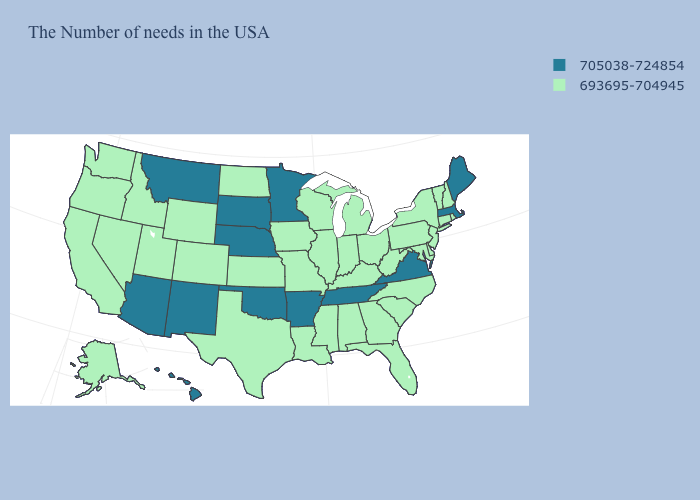What is the value of Nebraska?
Concise answer only. 705038-724854. What is the value of Colorado?
Short answer required. 693695-704945. What is the value of North Carolina?
Short answer required. 693695-704945. What is the highest value in states that border Virginia?
Quick response, please. 705038-724854. What is the lowest value in the USA?
Short answer required. 693695-704945. What is the lowest value in states that border Indiana?
Short answer required. 693695-704945. Name the states that have a value in the range 693695-704945?
Be succinct. Rhode Island, New Hampshire, Vermont, Connecticut, New York, New Jersey, Delaware, Maryland, Pennsylvania, North Carolina, South Carolina, West Virginia, Ohio, Florida, Georgia, Michigan, Kentucky, Indiana, Alabama, Wisconsin, Illinois, Mississippi, Louisiana, Missouri, Iowa, Kansas, Texas, North Dakota, Wyoming, Colorado, Utah, Idaho, Nevada, California, Washington, Oregon, Alaska. Does the map have missing data?
Give a very brief answer. No. Among the states that border Indiana , which have the highest value?
Give a very brief answer. Ohio, Michigan, Kentucky, Illinois. Name the states that have a value in the range 705038-724854?
Write a very short answer. Maine, Massachusetts, Virginia, Tennessee, Arkansas, Minnesota, Nebraska, Oklahoma, South Dakota, New Mexico, Montana, Arizona, Hawaii. Does Georgia have the highest value in the South?
Give a very brief answer. No. What is the lowest value in the USA?
Quick response, please. 693695-704945. Which states have the lowest value in the MidWest?
Quick response, please. Ohio, Michigan, Indiana, Wisconsin, Illinois, Missouri, Iowa, Kansas, North Dakota. What is the value of Florida?
Answer briefly. 693695-704945. What is the highest value in states that border Louisiana?
Give a very brief answer. 705038-724854. 